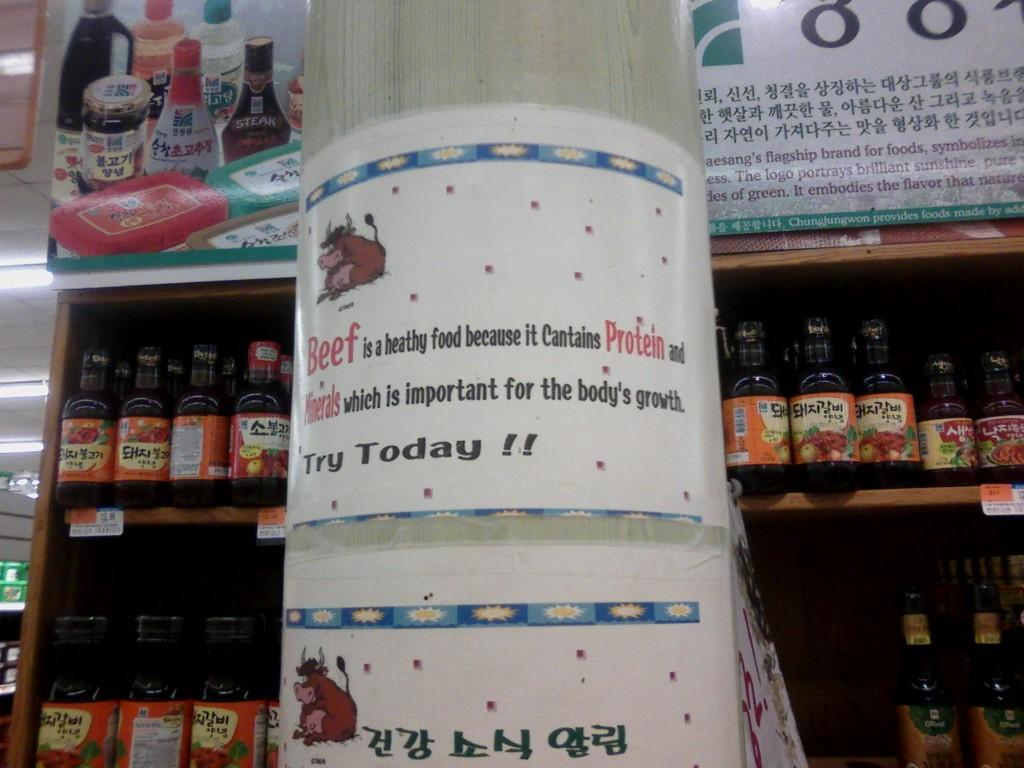<image>
Present a compact description of the photo's key features. The grocery store advertises beef as a healthy, protein filled food 